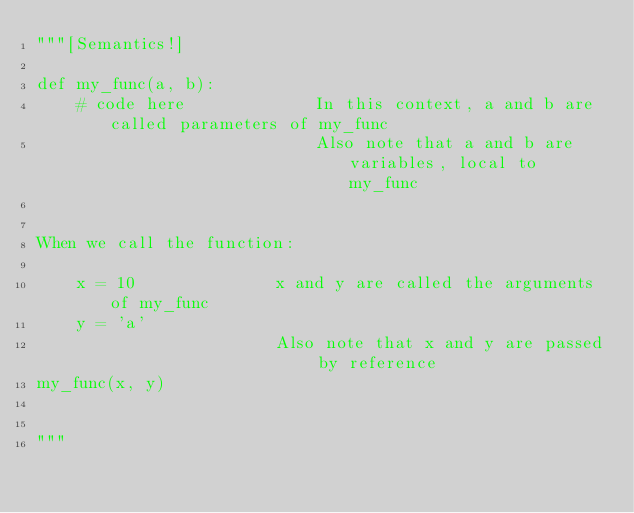Convert code to text. <code><loc_0><loc_0><loc_500><loc_500><_Python_>"""[Semantics!]

def my_func(a, b):
    # code here             In this context, a and b are called parameters of my_func
                            Also note that a and b are variables, local to my_func


When we call the function:

    x = 10              x and y are called the arguments of my_func
    y = 'a'
                        Also note that x and y are passed by reference
my_func(x, y)


"""

</code> 